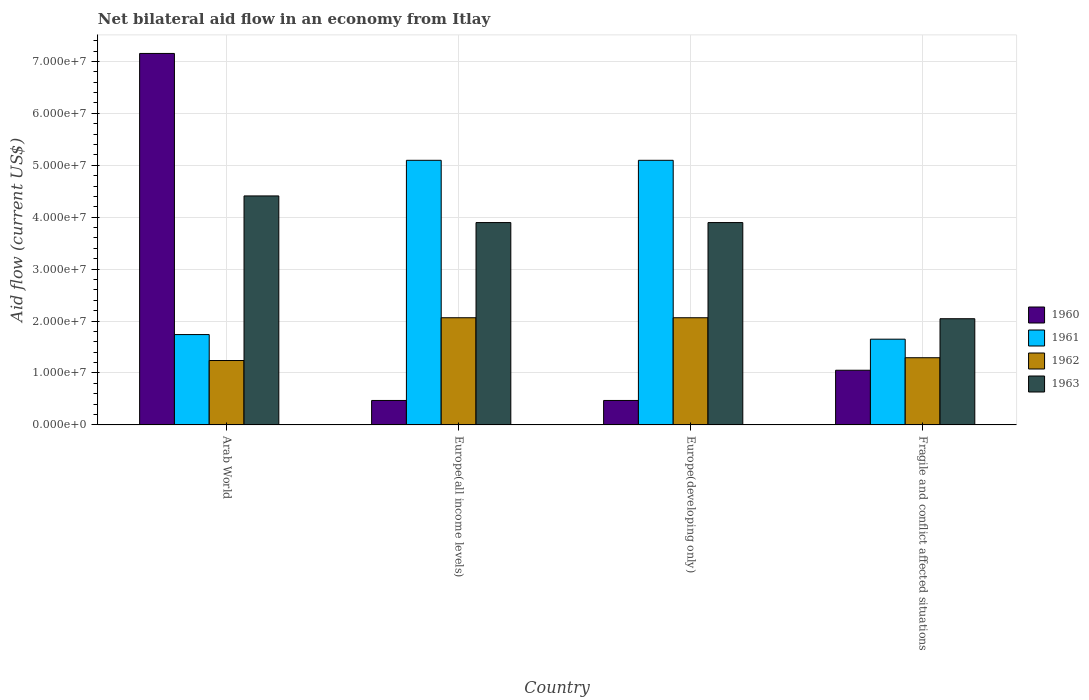How many different coloured bars are there?
Provide a succinct answer. 4. Are the number of bars per tick equal to the number of legend labels?
Your answer should be compact. Yes. How many bars are there on the 1st tick from the right?
Your response must be concise. 4. What is the label of the 4th group of bars from the left?
Your answer should be compact. Fragile and conflict affected situations. In how many cases, is the number of bars for a given country not equal to the number of legend labels?
Your response must be concise. 0. What is the net bilateral aid flow in 1961 in Fragile and conflict affected situations?
Provide a succinct answer. 1.65e+07. Across all countries, what is the maximum net bilateral aid flow in 1961?
Your response must be concise. 5.10e+07. Across all countries, what is the minimum net bilateral aid flow in 1962?
Your answer should be compact. 1.24e+07. In which country was the net bilateral aid flow in 1961 maximum?
Offer a terse response. Europe(all income levels). In which country was the net bilateral aid flow in 1961 minimum?
Provide a short and direct response. Fragile and conflict affected situations. What is the total net bilateral aid flow in 1961 in the graph?
Make the answer very short. 1.36e+08. What is the difference between the net bilateral aid flow in 1963 in Arab World and that in Europe(developing only)?
Your response must be concise. 5.13e+06. What is the difference between the net bilateral aid flow in 1961 in Arab World and the net bilateral aid flow in 1960 in Fragile and conflict affected situations?
Your answer should be very brief. 6.87e+06. What is the average net bilateral aid flow in 1961 per country?
Ensure brevity in your answer.  3.40e+07. What is the difference between the net bilateral aid flow of/in 1962 and net bilateral aid flow of/in 1963 in Arab World?
Your response must be concise. -3.17e+07. What is the ratio of the net bilateral aid flow in 1963 in Europe(developing only) to that in Fragile and conflict affected situations?
Your answer should be very brief. 1.91. Is the net bilateral aid flow in 1961 in Arab World less than that in Fragile and conflict affected situations?
Make the answer very short. No. What is the difference between the highest and the second highest net bilateral aid flow in 1962?
Make the answer very short. 7.70e+06. What is the difference between the highest and the lowest net bilateral aid flow in 1961?
Your response must be concise. 3.44e+07. In how many countries, is the net bilateral aid flow in 1963 greater than the average net bilateral aid flow in 1963 taken over all countries?
Keep it short and to the point. 3. What does the 2nd bar from the right in Arab World represents?
Give a very brief answer. 1962. What is the difference between two consecutive major ticks on the Y-axis?
Your answer should be compact. 1.00e+07. Are the values on the major ticks of Y-axis written in scientific E-notation?
Provide a short and direct response. Yes. Does the graph contain grids?
Your answer should be compact. Yes. Where does the legend appear in the graph?
Provide a short and direct response. Center right. How are the legend labels stacked?
Provide a short and direct response. Vertical. What is the title of the graph?
Make the answer very short. Net bilateral aid flow in an economy from Itlay. What is the label or title of the Y-axis?
Your answer should be compact. Aid flow (current US$). What is the Aid flow (current US$) of 1960 in Arab World?
Provide a succinct answer. 7.15e+07. What is the Aid flow (current US$) of 1961 in Arab World?
Offer a very short reply. 1.74e+07. What is the Aid flow (current US$) of 1962 in Arab World?
Keep it short and to the point. 1.24e+07. What is the Aid flow (current US$) in 1963 in Arab World?
Offer a terse response. 4.41e+07. What is the Aid flow (current US$) in 1960 in Europe(all income levels)?
Give a very brief answer. 4.71e+06. What is the Aid flow (current US$) in 1961 in Europe(all income levels)?
Make the answer very short. 5.10e+07. What is the Aid flow (current US$) in 1962 in Europe(all income levels)?
Give a very brief answer. 2.06e+07. What is the Aid flow (current US$) of 1963 in Europe(all income levels)?
Offer a terse response. 3.90e+07. What is the Aid flow (current US$) in 1960 in Europe(developing only)?
Provide a succinct answer. 4.71e+06. What is the Aid flow (current US$) in 1961 in Europe(developing only)?
Offer a terse response. 5.10e+07. What is the Aid flow (current US$) in 1962 in Europe(developing only)?
Provide a short and direct response. 2.06e+07. What is the Aid flow (current US$) of 1963 in Europe(developing only)?
Your answer should be compact. 3.90e+07. What is the Aid flow (current US$) in 1960 in Fragile and conflict affected situations?
Keep it short and to the point. 1.05e+07. What is the Aid flow (current US$) of 1961 in Fragile and conflict affected situations?
Provide a short and direct response. 1.65e+07. What is the Aid flow (current US$) of 1962 in Fragile and conflict affected situations?
Your response must be concise. 1.29e+07. What is the Aid flow (current US$) of 1963 in Fragile and conflict affected situations?
Provide a short and direct response. 2.04e+07. Across all countries, what is the maximum Aid flow (current US$) in 1960?
Keep it short and to the point. 7.15e+07. Across all countries, what is the maximum Aid flow (current US$) of 1961?
Your response must be concise. 5.10e+07. Across all countries, what is the maximum Aid flow (current US$) in 1962?
Give a very brief answer. 2.06e+07. Across all countries, what is the maximum Aid flow (current US$) of 1963?
Provide a succinct answer. 4.41e+07. Across all countries, what is the minimum Aid flow (current US$) in 1960?
Offer a very short reply. 4.71e+06. Across all countries, what is the minimum Aid flow (current US$) in 1961?
Your answer should be very brief. 1.65e+07. Across all countries, what is the minimum Aid flow (current US$) in 1962?
Your response must be concise. 1.24e+07. Across all countries, what is the minimum Aid flow (current US$) in 1963?
Give a very brief answer. 2.04e+07. What is the total Aid flow (current US$) of 1960 in the graph?
Offer a terse response. 9.15e+07. What is the total Aid flow (current US$) in 1961 in the graph?
Ensure brevity in your answer.  1.36e+08. What is the total Aid flow (current US$) of 1962 in the graph?
Provide a short and direct response. 6.66e+07. What is the total Aid flow (current US$) of 1963 in the graph?
Provide a short and direct response. 1.42e+08. What is the difference between the Aid flow (current US$) of 1960 in Arab World and that in Europe(all income levels)?
Your answer should be compact. 6.68e+07. What is the difference between the Aid flow (current US$) of 1961 in Arab World and that in Europe(all income levels)?
Your answer should be very brief. -3.36e+07. What is the difference between the Aid flow (current US$) of 1962 in Arab World and that in Europe(all income levels)?
Offer a very short reply. -8.24e+06. What is the difference between the Aid flow (current US$) in 1963 in Arab World and that in Europe(all income levels)?
Provide a succinct answer. 5.13e+06. What is the difference between the Aid flow (current US$) in 1960 in Arab World and that in Europe(developing only)?
Your answer should be compact. 6.68e+07. What is the difference between the Aid flow (current US$) in 1961 in Arab World and that in Europe(developing only)?
Offer a terse response. -3.36e+07. What is the difference between the Aid flow (current US$) in 1962 in Arab World and that in Europe(developing only)?
Offer a very short reply. -8.24e+06. What is the difference between the Aid flow (current US$) in 1963 in Arab World and that in Europe(developing only)?
Ensure brevity in your answer.  5.13e+06. What is the difference between the Aid flow (current US$) of 1960 in Arab World and that in Fragile and conflict affected situations?
Keep it short and to the point. 6.10e+07. What is the difference between the Aid flow (current US$) of 1961 in Arab World and that in Fragile and conflict affected situations?
Provide a short and direct response. 8.90e+05. What is the difference between the Aid flow (current US$) of 1962 in Arab World and that in Fragile and conflict affected situations?
Your answer should be very brief. -5.40e+05. What is the difference between the Aid flow (current US$) in 1963 in Arab World and that in Fragile and conflict affected situations?
Offer a terse response. 2.36e+07. What is the difference between the Aid flow (current US$) of 1960 in Europe(all income levels) and that in Europe(developing only)?
Make the answer very short. 0. What is the difference between the Aid flow (current US$) of 1961 in Europe(all income levels) and that in Europe(developing only)?
Offer a very short reply. 0. What is the difference between the Aid flow (current US$) of 1960 in Europe(all income levels) and that in Fragile and conflict affected situations?
Your response must be concise. -5.82e+06. What is the difference between the Aid flow (current US$) of 1961 in Europe(all income levels) and that in Fragile and conflict affected situations?
Your answer should be compact. 3.44e+07. What is the difference between the Aid flow (current US$) of 1962 in Europe(all income levels) and that in Fragile and conflict affected situations?
Keep it short and to the point. 7.70e+06. What is the difference between the Aid flow (current US$) of 1963 in Europe(all income levels) and that in Fragile and conflict affected situations?
Offer a very short reply. 1.85e+07. What is the difference between the Aid flow (current US$) in 1960 in Europe(developing only) and that in Fragile and conflict affected situations?
Ensure brevity in your answer.  -5.82e+06. What is the difference between the Aid flow (current US$) in 1961 in Europe(developing only) and that in Fragile and conflict affected situations?
Your answer should be very brief. 3.44e+07. What is the difference between the Aid flow (current US$) in 1962 in Europe(developing only) and that in Fragile and conflict affected situations?
Provide a succinct answer. 7.70e+06. What is the difference between the Aid flow (current US$) in 1963 in Europe(developing only) and that in Fragile and conflict affected situations?
Keep it short and to the point. 1.85e+07. What is the difference between the Aid flow (current US$) in 1960 in Arab World and the Aid flow (current US$) in 1961 in Europe(all income levels)?
Your response must be concise. 2.06e+07. What is the difference between the Aid flow (current US$) in 1960 in Arab World and the Aid flow (current US$) in 1962 in Europe(all income levels)?
Offer a very short reply. 5.09e+07. What is the difference between the Aid flow (current US$) in 1960 in Arab World and the Aid flow (current US$) in 1963 in Europe(all income levels)?
Offer a very short reply. 3.26e+07. What is the difference between the Aid flow (current US$) of 1961 in Arab World and the Aid flow (current US$) of 1962 in Europe(all income levels)?
Your answer should be compact. -3.24e+06. What is the difference between the Aid flow (current US$) of 1961 in Arab World and the Aid flow (current US$) of 1963 in Europe(all income levels)?
Offer a very short reply. -2.16e+07. What is the difference between the Aid flow (current US$) of 1962 in Arab World and the Aid flow (current US$) of 1963 in Europe(all income levels)?
Offer a terse response. -2.66e+07. What is the difference between the Aid flow (current US$) of 1960 in Arab World and the Aid flow (current US$) of 1961 in Europe(developing only)?
Provide a short and direct response. 2.06e+07. What is the difference between the Aid flow (current US$) in 1960 in Arab World and the Aid flow (current US$) in 1962 in Europe(developing only)?
Provide a succinct answer. 5.09e+07. What is the difference between the Aid flow (current US$) of 1960 in Arab World and the Aid flow (current US$) of 1963 in Europe(developing only)?
Give a very brief answer. 3.26e+07. What is the difference between the Aid flow (current US$) of 1961 in Arab World and the Aid flow (current US$) of 1962 in Europe(developing only)?
Your answer should be very brief. -3.24e+06. What is the difference between the Aid flow (current US$) in 1961 in Arab World and the Aid flow (current US$) in 1963 in Europe(developing only)?
Your response must be concise. -2.16e+07. What is the difference between the Aid flow (current US$) in 1962 in Arab World and the Aid flow (current US$) in 1963 in Europe(developing only)?
Offer a terse response. -2.66e+07. What is the difference between the Aid flow (current US$) in 1960 in Arab World and the Aid flow (current US$) in 1961 in Fragile and conflict affected situations?
Give a very brief answer. 5.50e+07. What is the difference between the Aid flow (current US$) of 1960 in Arab World and the Aid flow (current US$) of 1962 in Fragile and conflict affected situations?
Offer a very short reply. 5.86e+07. What is the difference between the Aid flow (current US$) in 1960 in Arab World and the Aid flow (current US$) in 1963 in Fragile and conflict affected situations?
Make the answer very short. 5.11e+07. What is the difference between the Aid flow (current US$) in 1961 in Arab World and the Aid flow (current US$) in 1962 in Fragile and conflict affected situations?
Keep it short and to the point. 4.46e+06. What is the difference between the Aid flow (current US$) in 1961 in Arab World and the Aid flow (current US$) in 1963 in Fragile and conflict affected situations?
Ensure brevity in your answer.  -3.05e+06. What is the difference between the Aid flow (current US$) in 1962 in Arab World and the Aid flow (current US$) in 1963 in Fragile and conflict affected situations?
Offer a terse response. -8.05e+06. What is the difference between the Aid flow (current US$) in 1960 in Europe(all income levels) and the Aid flow (current US$) in 1961 in Europe(developing only)?
Your answer should be very brief. -4.62e+07. What is the difference between the Aid flow (current US$) of 1960 in Europe(all income levels) and the Aid flow (current US$) of 1962 in Europe(developing only)?
Make the answer very short. -1.59e+07. What is the difference between the Aid flow (current US$) of 1960 in Europe(all income levels) and the Aid flow (current US$) of 1963 in Europe(developing only)?
Your response must be concise. -3.43e+07. What is the difference between the Aid flow (current US$) in 1961 in Europe(all income levels) and the Aid flow (current US$) in 1962 in Europe(developing only)?
Ensure brevity in your answer.  3.03e+07. What is the difference between the Aid flow (current US$) in 1961 in Europe(all income levels) and the Aid flow (current US$) in 1963 in Europe(developing only)?
Your response must be concise. 1.20e+07. What is the difference between the Aid flow (current US$) of 1962 in Europe(all income levels) and the Aid flow (current US$) of 1963 in Europe(developing only)?
Give a very brief answer. -1.83e+07. What is the difference between the Aid flow (current US$) of 1960 in Europe(all income levels) and the Aid flow (current US$) of 1961 in Fragile and conflict affected situations?
Offer a very short reply. -1.18e+07. What is the difference between the Aid flow (current US$) in 1960 in Europe(all income levels) and the Aid flow (current US$) in 1962 in Fragile and conflict affected situations?
Provide a short and direct response. -8.23e+06. What is the difference between the Aid flow (current US$) in 1960 in Europe(all income levels) and the Aid flow (current US$) in 1963 in Fragile and conflict affected situations?
Offer a very short reply. -1.57e+07. What is the difference between the Aid flow (current US$) in 1961 in Europe(all income levels) and the Aid flow (current US$) in 1962 in Fragile and conflict affected situations?
Your answer should be compact. 3.80e+07. What is the difference between the Aid flow (current US$) of 1961 in Europe(all income levels) and the Aid flow (current US$) of 1963 in Fragile and conflict affected situations?
Your response must be concise. 3.05e+07. What is the difference between the Aid flow (current US$) of 1960 in Europe(developing only) and the Aid flow (current US$) of 1961 in Fragile and conflict affected situations?
Ensure brevity in your answer.  -1.18e+07. What is the difference between the Aid flow (current US$) in 1960 in Europe(developing only) and the Aid flow (current US$) in 1962 in Fragile and conflict affected situations?
Your response must be concise. -8.23e+06. What is the difference between the Aid flow (current US$) in 1960 in Europe(developing only) and the Aid flow (current US$) in 1963 in Fragile and conflict affected situations?
Offer a very short reply. -1.57e+07. What is the difference between the Aid flow (current US$) of 1961 in Europe(developing only) and the Aid flow (current US$) of 1962 in Fragile and conflict affected situations?
Give a very brief answer. 3.80e+07. What is the difference between the Aid flow (current US$) of 1961 in Europe(developing only) and the Aid flow (current US$) of 1963 in Fragile and conflict affected situations?
Provide a short and direct response. 3.05e+07. What is the average Aid flow (current US$) in 1960 per country?
Your answer should be compact. 2.29e+07. What is the average Aid flow (current US$) of 1961 per country?
Offer a very short reply. 3.40e+07. What is the average Aid flow (current US$) of 1962 per country?
Provide a short and direct response. 1.67e+07. What is the average Aid flow (current US$) of 1963 per country?
Your response must be concise. 3.56e+07. What is the difference between the Aid flow (current US$) in 1960 and Aid flow (current US$) in 1961 in Arab World?
Provide a short and direct response. 5.41e+07. What is the difference between the Aid flow (current US$) in 1960 and Aid flow (current US$) in 1962 in Arab World?
Your answer should be compact. 5.91e+07. What is the difference between the Aid flow (current US$) in 1960 and Aid flow (current US$) in 1963 in Arab World?
Provide a succinct answer. 2.74e+07. What is the difference between the Aid flow (current US$) of 1961 and Aid flow (current US$) of 1962 in Arab World?
Your response must be concise. 5.00e+06. What is the difference between the Aid flow (current US$) of 1961 and Aid flow (current US$) of 1963 in Arab World?
Provide a succinct answer. -2.67e+07. What is the difference between the Aid flow (current US$) in 1962 and Aid flow (current US$) in 1963 in Arab World?
Offer a very short reply. -3.17e+07. What is the difference between the Aid flow (current US$) in 1960 and Aid flow (current US$) in 1961 in Europe(all income levels)?
Your answer should be compact. -4.62e+07. What is the difference between the Aid flow (current US$) of 1960 and Aid flow (current US$) of 1962 in Europe(all income levels)?
Ensure brevity in your answer.  -1.59e+07. What is the difference between the Aid flow (current US$) in 1960 and Aid flow (current US$) in 1963 in Europe(all income levels)?
Provide a short and direct response. -3.43e+07. What is the difference between the Aid flow (current US$) of 1961 and Aid flow (current US$) of 1962 in Europe(all income levels)?
Provide a succinct answer. 3.03e+07. What is the difference between the Aid flow (current US$) in 1961 and Aid flow (current US$) in 1963 in Europe(all income levels)?
Provide a succinct answer. 1.20e+07. What is the difference between the Aid flow (current US$) in 1962 and Aid flow (current US$) in 1963 in Europe(all income levels)?
Make the answer very short. -1.83e+07. What is the difference between the Aid flow (current US$) of 1960 and Aid flow (current US$) of 1961 in Europe(developing only)?
Offer a very short reply. -4.62e+07. What is the difference between the Aid flow (current US$) in 1960 and Aid flow (current US$) in 1962 in Europe(developing only)?
Give a very brief answer. -1.59e+07. What is the difference between the Aid flow (current US$) in 1960 and Aid flow (current US$) in 1963 in Europe(developing only)?
Provide a short and direct response. -3.43e+07. What is the difference between the Aid flow (current US$) in 1961 and Aid flow (current US$) in 1962 in Europe(developing only)?
Offer a very short reply. 3.03e+07. What is the difference between the Aid flow (current US$) in 1961 and Aid flow (current US$) in 1963 in Europe(developing only)?
Your response must be concise. 1.20e+07. What is the difference between the Aid flow (current US$) in 1962 and Aid flow (current US$) in 1963 in Europe(developing only)?
Keep it short and to the point. -1.83e+07. What is the difference between the Aid flow (current US$) of 1960 and Aid flow (current US$) of 1961 in Fragile and conflict affected situations?
Provide a succinct answer. -5.98e+06. What is the difference between the Aid flow (current US$) in 1960 and Aid flow (current US$) in 1962 in Fragile and conflict affected situations?
Your answer should be very brief. -2.41e+06. What is the difference between the Aid flow (current US$) of 1960 and Aid flow (current US$) of 1963 in Fragile and conflict affected situations?
Offer a very short reply. -9.92e+06. What is the difference between the Aid flow (current US$) in 1961 and Aid flow (current US$) in 1962 in Fragile and conflict affected situations?
Offer a terse response. 3.57e+06. What is the difference between the Aid flow (current US$) of 1961 and Aid flow (current US$) of 1963 in Fragile and conflict affected situations?
Offer a terse response. -3.94e+06. What is the difference between the Aid flow (current US$) of 1962 and Aid flow (current US$) of 1963 in Fragile and conflict affected situations?
Ensure brevity in your answer.  -7.51e+06. What is the ratio of the Aid flow (current US$) of 1960 in Arab World to that in Europe(all income levels)?
Your response must be concise. 15.19. What is the ratio of the Aid flow (current US$) in 1961 in Arab World to that in Europe(all income levels)?
Offer a terse response. 0.34. What is the ratio of the Aid flow (current US$) of 1962 in Arab World to that in Europe(all income levels)?
Your answer should be compact. 0.6. What is the ratio of the Aid flow (current US$) in 1963 in Arab World to that in Europe(all income levels)?
Offer a terse response. 1.13. What is the ratio of the Aid flow (current US$) in 1960 in Arab World to that in Europe(developing only)?
Make the answer very short. 15.19. What is the ratio of the Aid flow (current US$) of 1961 in Arab World to that in Europe(developing only)?
Your answer should be very brief. 0.34. What is the ratio of the Aid flow (current US$) in 1962 in Arab World to that in Europe(developing only)?
Provide a short and direct response. 0.6. What is the ratio of the Aid flow (current US$) of 1963 in Arab World to that in Europe(developing only)?
Your answer should be very brief. 1.13. What is the ratio of the Aid flow (current US$) of 1960 in Arab World to that in Fragile and conflict affected situations?
Offer a terse response. 6.79. What is the ratio of the Aid flow (current US$) in 1961 in Arab World to that in Fragile and conflict affected situations?
Offer a terse response. 1.05. What is the ratio of the Aid flow (current US$) of 1962 in Arab World to that in Fragile and conflict affected situations?
Keep it short and to the point. 0.96. What is the ratio of the Aid flow (current US$) in 1963 in Arab World to that in Fragile and conflict affected situations?
Offer a terse response. 2.16. What is the ratio of the Aid flow (current US$) of 1962 in Europe(all income levels) to that in Europe(developing only)?
Offer a terse response. 1. What is the ratio of the Aid flow (current US$) of 1963 in Europe(all income levels) to that in Europe(developing only)?
Make the answer very short. 1. What is the ratio of the Aid flow (current US$) in 1960 in Europe(all income levels) to that in Fragile and conflict affected situations?
Your response must be concise. 0.45. What is the ratio of the Aid flow (current US$) in 1961 in Europe(all income levels) to that in Fragile and conflict affected situations?
Keep it short and to the point. 3.09. What is the ratio of the Aid flow (current US$) in 1962 in Europe(all income levels) to that in Fragile and conflict affected situations?
Provide a succinct answer. 1.6. What is the ratio of the Aid flow (current US$) of 1963 in Europe(all income levels) to that in Fragile and conflict affected situations?
Give a very brief answer. 1.91. What is the ratio of the Aid flow (current US$) of 1960 in Europe(developing only) to that in Fragile and conflict affected situations?
Give a very brief answer. 0.45. What is the ratio of the Aid flow (current US$) in 1961 in Europe(developing only) to that in Fragile and conflict affected situations?
Keep it short and to the point. 3.09. What is the ratio of the Aid flow (current US$) in 1962 in Europe(developing only) to that in Fragile and conflict affected situations?
Your answer should be compact. 1.6. What is the ratio of the Aid flow (current US$) of 1963 in Europe(developing only) to that in Fragile and conflict affected situations?
Give a very brief answer. 1.91. What is the difference between the highest and the second highest Aid flow (current US$) in 1960?
Offer a terse response. 6.10e+07. What is the difference between the highest and the second highest Aid flow (current US$) of 1962?
Your answer should be very brief. 0. What is the difference between the highest and the second highest Aid flow (current US$) of 1963?
Offer a terse response. 5.13e+06. What is the difference between the highest and the lowest Aid flow (current US$) in 1960?
Ensure brevity in your answer.  6.68e+07. What is the difference between the highest and the lowest Aid flow (current US$) of 1961?
Offer a terse response. 3.44e+07. What is the difference between the highest and the lowest Aid flow (current US$) of 1962?
Keep it short and to the point. 8.24e+06. What is the difference between the highest and the lowest Aid flow (current US$) in 1963?
Offer a very short reply. 2.36e+07. 